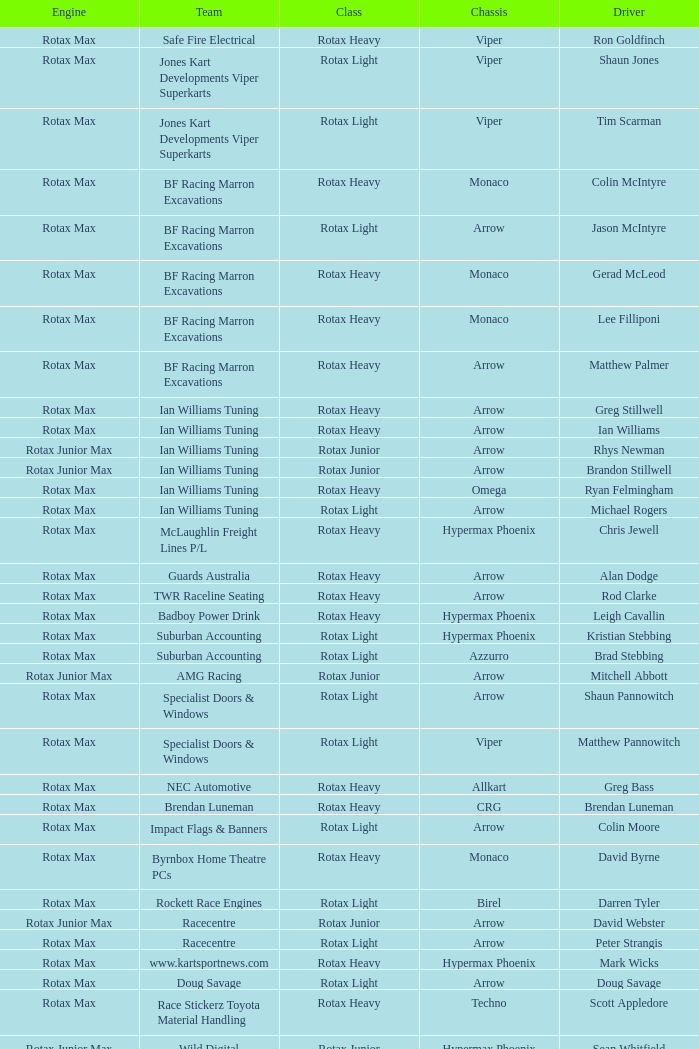Which team does Colin Moore drive for? Impact Flags & Banners. 